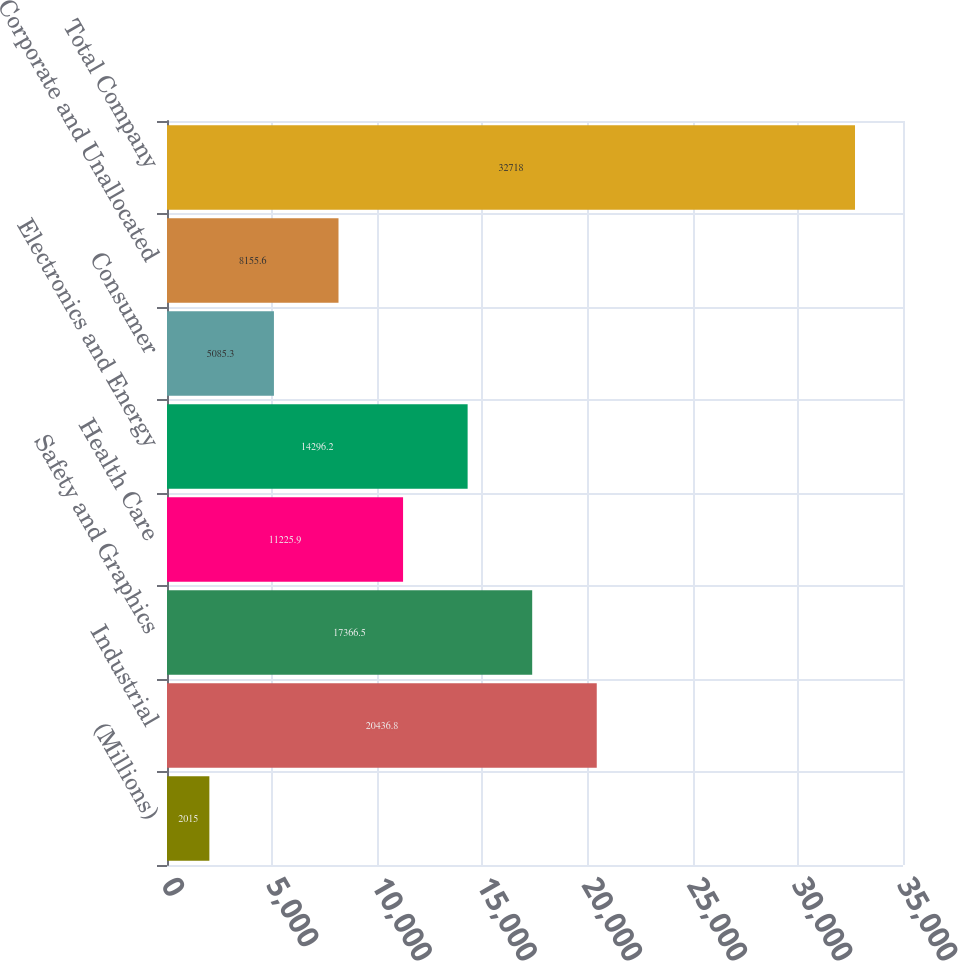<chart> <loc_0><loc_0><loc_500><loc_500><bar_chart><fcel>(Millions)<fcel>Industrial<fcel>Safety and Graphics<fcel>Health Care<fcel>Electronics and Energy<fcel>Consumer<fcel>Corporate and Unallocated<fcel>Total Company<nl><fcel>2015<fcel>20436.8<fcel>17366.5<fcel>11225.9<fcel>14296.2<fcel>5085.3<fcel>8155.6<fcel>32718<nl></chart> 